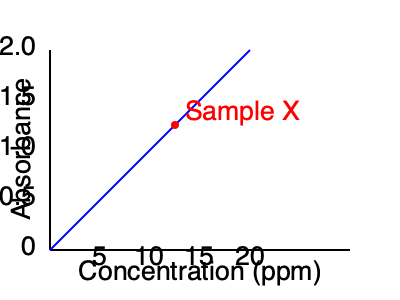A standard curve for a water contaminant is shown above. If Sample X has an absorbance of 1.25, what is its approximate concentration in parts per million (ppm)? To determine the concentration of Sample X using the standard curve, we need to follow these steps:

1. Locate the absorbance value of Sample X on the y-axis (1.25).
2. Draw a horizontal line from this point to intersect with the standard curve.
3. From the intersection point, draw a vertical line down to the x-axis (concentration).
4. Read the concentration value where the vertical line meets the x-axis.

In this case:

1. The absorbance of Sample X is 1.25, which falls between 1.0 and 1.5 on the y-axis.
2. Drawing a horizontal line from 1.25 on the y-axis, we see it intersects the standard curve approximately midway between the 10 ppm and 15 ppm marks.
3. Drawing a vertical line down from this intersection point, we reach the x-axis between 10 and 15 ppm.
4. The exact midpoint between 10 and 15 is 12.5 ppm.

Therefore, the approximate concentration of Sample X is 12.5 ppm.
Answer: 12.5 ppm 